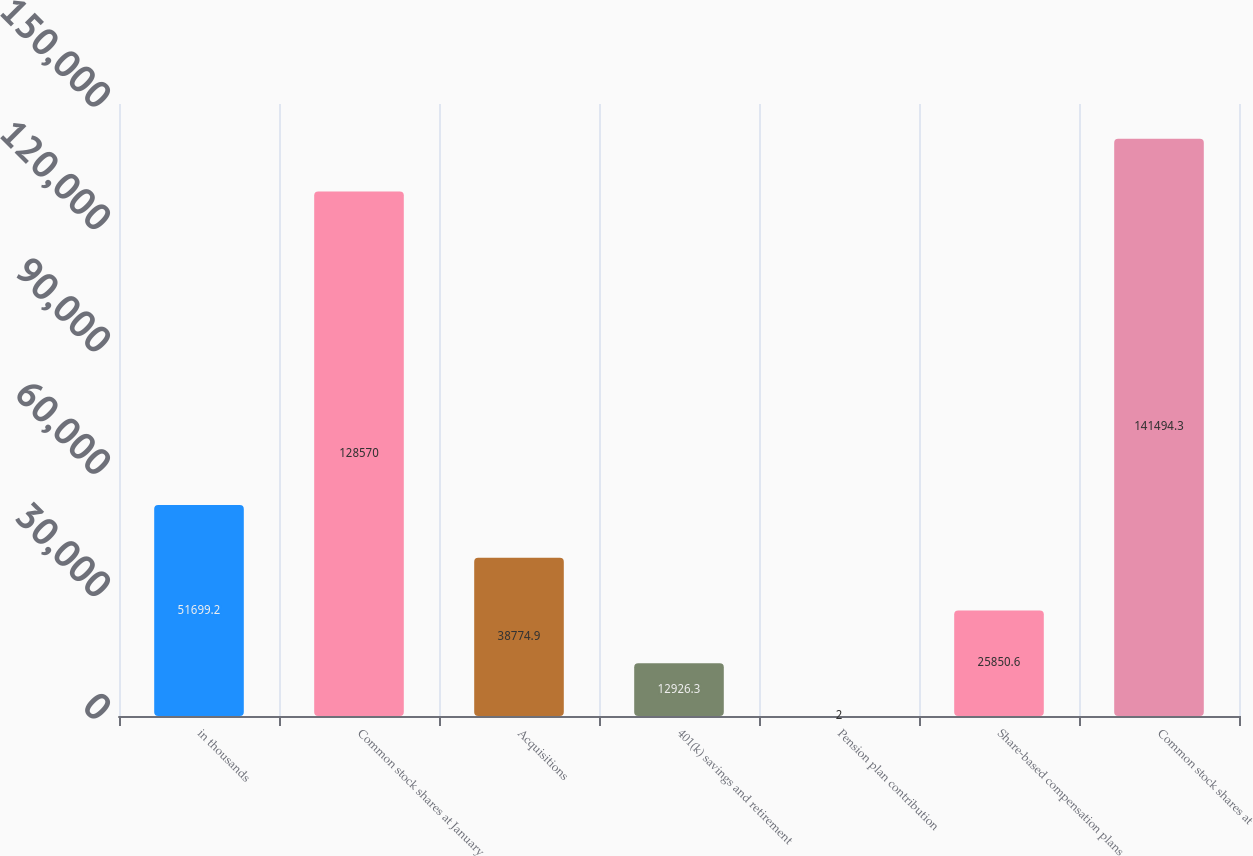Convert chart to OTSL. <chart><loc_0><loc_0><loc_500><loc_500><bar_chart><fcel>in thousands<fcel>Common stock shares at January<fcel>Acquisitions<fcel>401(k) savings and retirement<fcel>Pension plan contribution<fcel>Share-based compensation plans<fcel>Common stock shares at<nl><fcel>51699.2<fcel>128570<fcel>38774.9<fcel>12926.3<fcel>2<fcel>25850.6<fcel>141494<nl></chart> 